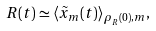Convert formula to latex. <formula><loc_0><loc_0><loc_500><loc_500>R ( t ) \simeq \langle \tilde { x } _ { m } ( t ) \rangle _ { \rho _ { _ { R } } ( 0 ) , m } ,</formula> 